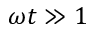<formula> <loc_0><loc_0><loc_500><loc_500>\omega t \gg 1</formula> 